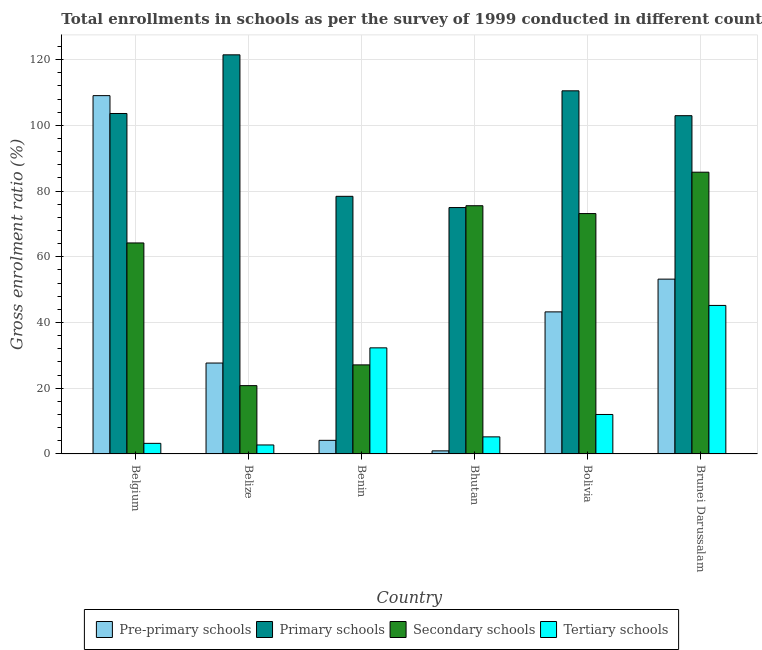Are the number of bars per tick equal to the number of legend labels?
Provide a succinct answer. Yes. Are the number of bars on each tick of the X-axis equal?
Ensure brevity in your answer.  Yes. How many bars are there on the 2nd tick from the right?
Offer a terse response. 4. In how many cases, is the number of bars for a given country not equal to the number of legend labels?
Give a very brief answer. 0. What is the gross enrolment ratio in primary schools in Bolivia?
Your response must be concise. 110.51. Across all countries, what is the maximum gross enrolment ratio in pre-primary schools?
Provide a succinct answer. 109.05. Across all countries, what is the minimum gross enrolment ratio in primary schools?
Offer a terse response. 74.99. In which country was the gross enrolment ratio in pre-primary schools maximum?
Provide a short and direct response. Belgium. In which country was the gross enrolment ratio in pre-primary schools minimum?
Offer a terse response. Bhutan. What is the total gross enrolment ratio in primary schools in the graph?
Make the answer very short. 591.91. What is the difference between the gross enrolment ratio in secondary schools in Belgium and that in Benin?
Make the answer very short. 37.11. What is the difference between the gross enrolment ratio in tertiary schools in Belgium and the gross enrolment ratio in secondary schools in Bhutan?
Offer a terse response. -72.31. What is the average gross enrolment ratio in tertiary schools per country?
Ensure brevity in your answer.  16.78. What is the difference between the gross enrolment ratio in pre-primary schools and gross enrolment ratio in tertiary schools in Belize?
Give a very brief answer. 24.92. In how many countries, is the gross enrolment ratio in primary schools greater than 48 %?
Make the answer very short. 6. What is the ratio of the gross enrolment ratio in primary schools in Bolivia to that in Brunei Darussalam?
Your response must be concise. 1.07. Is the gross enrolment ratio in tertiary schools in Benin less than that in Bolivia?
Your response must be concise. No. What is the difference between the highest and the second highest gross enrolment ratio in secondary schools?
Your answer should be compact. 10.2. What is the difference between the highest and the lowest gross enrolment ratio in pre-primary schools?
Keep it short and to the point. 108.1. What does the 1st bar from the left in Brunei Darussalam represents?
Give a very brief answer. Pre-primary schools. What does the 2nd bar from the right in Bolivia represents?
Your answer should be compact. Secondary schools. Is it the case that in every country, the sum of the gross enrolment ratio in pre-primary schools and gross enrolment ratio in primary schools is greater than the gross enrolment ratio in secondary schools?
Your response must be concise. Yes. How many bars are there?
Keep it short and to the point. 24. What is the difference between two consecutive major ticks on the Y-axis?
Your response must be concise. 20. Are the values on the major ticks of Y-axis written in scientific E-notation?
Offer a very short reply. No. Does the graph contain any zero values?
Keep it short and to the point. No. How are the legend labels stacked?
Make the answer very short. Horizontal. What is the title of the graph?
Offer a very short reply. Total enrollments in schools as per the survey of 1999 conducted in different countries. What is the Gross enrolment ratio (%) in Pre-primary schools in Belgium?
Ensure brevity in your answer.  109.05. What is the Gross enrolment ratio (%) in Primary schools in Belgium?
Offer a very short reply. 103.61. What is the Gross enrolment ratio (%) in Secondary schools in Belgium?
Offer a very short reply. 64.22. What is the Gross enrolment ratio (%) in Tertiary schools in Belgium?
Your response must be concise. 3.23. What is the Gross enrolment ratio (%) in Pre-primary schools in Belize?
Offer a very short reply. 27.67. What is the Gross enrolment ratio (%) of Primary schools in Belize?
Your answer should be compact. 121.46. What is the Gross enrolment ratio (%) of Secondary schools in Belize?
Provide a succinct answer. 20.79. What is the Gross enrolment ratio (%) in Tertiary schools in Belize?
Ensure brevity in your answer.  2.74. What is the Gross enrolment ratio (%) in Pre-primary schools in Benin?
Your answer should be very brief. 4.15. What is the Gross enrolment ratio (%) of Primary schools in Benin?
Give a very brief answer. 78.4. What is the Gross enrolment ratio (%) in Secondary schools in Benin?
Your answer should be compact. 27.11. What is the Gross enrolment ratio (%) of Tertiary schools in Benin?
Ensure brevity in your answer.  32.29. What is the Gross enrolment ratio (%) in Pre-primary schools in Bhutan?
Make the answer very short. 0.94. What is the Gross enrolment ratio (%) in Primary schools in Bhutan?
Keep it short and to the point. 74.99. What is the Gross enrolment ratio (%) of Secondary schools in Bhutan?
Offer a terse response. 75.54. What is the Gross enrolment ratio (%) in Tertiary schools in Bhutan?
Provide a short and direct response. 5.21. What is the Gross enrolment ratio (%) of Pre-primary schools in Bolivia?
Your answer should be compact. 43.24. What is the Gross enrolment ratio (%) in Primary schools in Bolivia?
Provide a succinct answer. 110.51. What is the Gross enrolment ratio (%) of Secondary schools in Bolivia?
Make the answer very short. 73.16. What is the Gross enrolment ratio (%) of Tertiary schools in Bolivia?
Ensure brevity in your answer.  12.02. What is the Gross enrolment ratio (%) in Pre-primary schools in Brunei Darussalam?
Ensure brevity in your answer.  53.2. What is the Gross enrolment ratio (%) in Primary schools in Brunei Darussalam?
Keep it short and to the point. 102.94. What is the Gross enrolment ratio (%) in Secondary schools in Brunei Darussalam?
Give a very brief answer. 85.75. What is the Gross enrolment ratio (%) in Tertiary schools in Brunei Darussalam?
Your answer should be compact. 45.2. Across all countries, what is the maximum Gross enrolment ratio (%) in Pre-primary schools?
Make the answer very short. 109.05. Across all countries, what is the maximum Gross enrolment ratio (%) of Primary schools?
Ensure brevity in your answer.  121.46. Across all countries, what is the maximum Gross enrolment ratio (%) in Secondary schools?
Offer a very short reply. 85.75. Across all countries, what is the maximum Gross enrolment ratio (%) in Tertiary schools?
Offer a terse response. 45.2. Across all countries, what is the minimum Gross enrolment ratio (%) in Pre-primary schools?
Provide a short and direct response. 0.94. Across all countries, what is the minimum Gross enrolment ratio (%) in Primary schools?
Your response must be concise. 74.99. Across all countries, what is the minimum Gross enrolment ratio (%) in Secondary schools?
Ensure brevity in your answer.  20.79. Across all countries, what is the minimum Gross enrolment ratio (%) of Tertiary schools?
Your answer should be compact. 2.74. What is the total Gross enrolment ratio (%) in Pre-primary schools in the graph?
Offer a very short reply. 238.25. What is the total Gross enrolment ratio (%) in Primary schools in the graph?
Provide a succinct answer. 591.91. What is the total Gross enrolment ratio (%) of Secondary schools in the graph?
Provide a succinct answer. 346.56. What is the total Gross enrolment ratio (%) of Tertiary schools in the graph?
Provide a short and direct response. 100.69. What is the difference between the Gross enrolment ratio (%) in Pre-primary schools in Belgium and that in Belize?
Give a very brief answer. 81.38. What is the difference between the Gross enrolment ratio (%) of Primary schools in Belgium and that in Belize?
Offer a very short reply. -17.85. What is the difference between the Gross enrolment ratio (%) in Secondary schools in Belgium and that in Belize?
Make the answer very short. 43.42. What is the difference between the Gross enrolment ratio (%) in Tertiary schools in Belgium and that in Belize?
Your answer should be very brief. 0.49. What is the difference between the Gross enrolment ratio (%) of Pre-primary schools in Belgium and that in Benin?
Offer a very short reply. 104.89. What is the difference between the Gross enrolment ratio (%) of Primary schools in Belgium and that in Benin?
Your answer should be compact. 25.21. What is the difference between the Gross enrolment ratio (%) in Secondary schools in Belgium and that in Benin?
Give a very brief answer. 37.11. What is the difference between the Gross enrolment ratio (%) of Tertiary schools in Belgium and that in Benin?
Offer a very short reply. -29.06. What is the difference between the Gross enrolment ratio (%) of Pre-primary schools in Belgium and that in Bhutan?
Your response must be concise. 108.1. What is the difference between the Gross enrolment ratio (%) in Primary schools in Belgium and that in Bhutan?
Offer a very short reply. 28.62. What is the difference between the Gross enrolment ratio (%) in Secondary schools in Belgium and that in Bhutan?
Your answer should be very brief. -11.33. What is the difference between the Gross enrolment ratio (%) of Tertiary schools in Belgium and that in Bhutan?
Your answer should be compact. -1.98. What is the difference between the Gross enrolment ratio (%) of Pre-primary schools in Belgium and that in Bolivia?
Offer a terse response. 65.81. What is the difference between the Gross enrolment ratio (%) of Primary schools in Belgium and that in Bolivia?
Offer a very short reply. -6.9. What is the difference between the Gross enrolment ratio (%) in Secondary schools in Belgium and that in Bolivia?
Ensure brevity in your answer.  -8.94. What is the difference between the Gross enrolment ratio (%) of Tertiary schools in Belgium and that in Bolivia?
Your answer should be very brief. -8.79. What is the difference between the Gross enrolment ratio (%) in Pre-primary schools in Belgium and that in Brunei Darussalam?
Give a very brief answer. 55.84. What is the difference between the Gross enrolment ratio (%) of Primary schools in Belgium and that in Brunei Darussalam?
Your answer should be very brief. 0.67. What is the difference between the Gross enrolment ratio (%) of Secondary schools in Belgium and that in Brunei Darussalam?
Keep it short and to the point. -21.53. What is the difference between the Gross enrolment ratio (%) of Tertiary schools in Belgium and that in Brunei Darussalam?
Make the answer very short. -41.97. What is the difference between the Gross enrolment ratio (%) in Pre-primary schools in Belize and that in Benin?
Give a very brief answer. 23.52. What is the difference between the Gross enrolment ratio (%) of Primary schools in Belize and that in Benin?
Offer a very short reply. 43.06. What is the difference between the Gross enrolment ratio (%) in Secondary schools in Belize and that in Benin?
Offer a terse response. -6.31. What is the difference between the Gross enrolment ratio (%) of Tertiary schools in Belize and that in Benin?
Ensure brevity in your answer.  -29.55. What is the difference between the Gross enrolment ratio (%) of Pre-primary schools in Belize and that in Bhutan?
Provide a short and direct response. 26.73. What is the difference between the Gross enrolment ratio (%) of Primary schools in Belize and that in Bhutan?
Provide a short and direct response. 46.47. What is the difference between the Gross enrolment ratio (%) in Secondary schools in Belize and that in Bhutan?
Your response must be concise. -54.75. What is the difference between the Gross enrolment ratio (%) in Tertiary schools in Belize and that in Bhutan?
Make the answer very short. -2.46. What is the difference between the Gross enrolment ratio (%) of Pre-primary schools in Belize and that in Bolivia?
Give a very brief answer. -15.57. What is the difference between the Gross enrolment ratio (%) in Primary schools in Belize and that in Bolivia?
Give a very brief answer. 10.95. What is the difference between the Gross enrolment ratio (%) of Secondary schools in Belize and that in Bolivia?
Offer a terse response. -52.36. What is the difference between the Gross enrolment ratio (%) of Tertiary schools in Belize and that in Bolivia?
Your answer should be very brief. -9.28. What is the difference between the Gross enrolment ratio (%) of Pre-primary schools in Belize and that in Brunei Darussalam?
Your answer should be compact. -25.53. What is the difference between the Gross enrolment ratio (%) in Primary schools in Belize and that in Brunei Darussalam?
Make the answer very short. 18.52. What is the difference between the Gross enrolment ratio (%) of Secondary schools in Belize and that in Brunei Darussalam?
Provide a succinct answer. -64.95. What is the difference between the Gross enrolment ratio (%) in Tertiary schools in Belize and that in Brunei Darussalam?
Offer a terse response. -42.46. What is the difference between the Gross enrolment ratio (%) in Pre-primary schools in Benin and that in Bhutan?
Your answer should be very brief. 3.21. What is the difference between the Gross enrolment ratio (%) in Primary schools in Benin and that in Bhutan?
Provide a short and direct response. 3.42. What is the difference between the Gross enrolment ratio (%) of Secondary schools in Benin and that in Bhutan?
Your answer should be very brief. -48.43. What is the difference between the Gross enrolment ratio (%) in Tertiary schools in Benin and that in Bhutan?
Keep it short and to the point. 27.09. What is the difference between the Gross enrolment ratio (%) in Pre-primary schools in Benin and that in Bolivia?
Ensure brevity in your answer.  -39.09. What is the difference between the Gross enrolment ratio (%) in Primary schools in Benin and that in Bolivia?
Your response must be concise. -32.1. What is the difference between the Gross enrolment ratio (%) of Secondary schools in Benin and that in Bolivia?
Ensure brevity in your answer.  -46.05. What is the difference between the Gross enrolment ratio (%) in Tertiary schools in Benin and that in Bolivia?
Keep it short and to the point. 20.27. What is the difference between the Gross enrolment ratio (%) in Pre-primary schools in Benin and that in Brunei Darussalam?
Your answer should be very brief. -49.05. What is the difference between the Gross enrolment ratio (%) of Primary schools in Benin and that in Brunei Darussalam?
Give a very brief answer. -24.54. What is the difference between the Gross enrolment ratio (%) in Secondary schools in Benin and that in Brunei Darussalam?
Offer a very short reply. -58.64. What is the difference between the Gross enrolment ratio (%) in Tertiary schools in Benin and that in Brunei Darussalam?
Offer a very short reply. -12.91. What is the difference between the Gross enrolment ratio (%) in Pre-primary schools in Bhutan and that in Bolivia?
Provide a succinct answer. -42.3. What is the difference between the Gross enrolment ratio (%) in Primary schools in Bhutan and that in Bolivia?
Offer a terse response. -35.52. What is the difference between the Gross enrolment ratio (%) in Secondary schools in Bhutan and that in Bolivia?
Give a very brief answer. 2.39. What is the difference between the Gross enrolment ratio (%) of Tertiary schools in Bhutan and that in Bolivia?
Your response must be concise. -6.81. What is the difference between the Gross enrolment ratio (%) of Pre-primary schools in Bhutan and that in Brunei Darussalam?
Ensure brevity in your answer.  -52.26. What is the difference between the Gross enrolment ratio (%) in Primary schools in Bhutan and that in Brunei Darussalam?
Give a very brief answer. -27.95. What is the difference between the Gross enrolment ratio (%) in Secondary schools in Bhutan and that in Brunei Darussalam?
Provide a short and direct response. -10.2. What is the difference between the Gross enrolment ratio (%) of Tertiary schools in Bhutan and that in Brunei Darussalam?
Your answer should be compact. -40. What is the difference between the Gross enrolment ratio (%) in Pre-primary schools in Bolivia and that in Brunei Darussalam?
Give a very brief answer. -9.96. What is the difference between the Gross enrolment ratio (%) of Primary schools in Bolivia and that in Brunei Darussalam?
Your answer should be compact. 7.57. What is the difference between the Gross enrolment ratio (%) of Secondary schools in Bolivia and that in Brunei Darussalam?
Offer a terse response. -12.59. What is the difference between the Gross enrolment ratio (%) in Tertiary schools in Bolivia and that in Brunei Darussalam?
Ensure brevity in your answer.  -33.18. What is the difference between the Gross enrolment ratio (%) of Pre-primary schools in Belgium and the Gross enrolment ratio (%) of Primary schools in Belize?
Provide a succinct answer. -12.41. What is the difference between the Gross enrolment ratio (%) of Pre-primary schools in Belgium and the Gross enrolment ratio (%) of Secondary schools in Belize?
Your answer should be compact. 88.25. What is the difference between the Gross enrolment ratio (%) of Pre-primary schools in Belgium and the Gross enrolment ratio (%) of Tertiary schools in Belize?
Offer a very short reply. 106.3. What is the difference between the Gross enrolment ratio (%) of Primary schools in Belgium and the Gross enrolment ratio (%) of Secondary schools in Belize?
Offer a terse response. 82.82. What is the difference between the Gross enrolment ratio (%) of Primary schools in Belgium and the Gross enrolment ratio (%) of Tertiary schools in Belize?
Keep it short and to the point. 100.87. What is the difference between the Gross enrolment ratio (%) in Secondary schools in Belgium and the Gross enrolment ratio (%) in Tertiary schools in Belize?
Offer a terse response. 61.47. What is the difference between the Gross enrolment ratio (%) of Pre-primary schools in Belgium and the Gross enrolment ratio (%) of Primary schools in Benin?
Offer a terse response. 30.64. What is the difference between the Gross enrolment ratio (%) in Pre-primary schools in Belgium and the Gross enrolment ratio (%) in Secondary schools in Benin?
Provide a succinct answer. 81.94. What is the difference between the Gross enrolment ratio (%) of Pre-primary schools in Belgium and the Gross enrolment ratio (%) of Tertiary schools in Benin?
Offer a very short reply. 76.75. What is the difference between the Gross enrolment ratio (%) in Primary schools in Belgium and the Gross enrolment ratio (%) in Secondary schools in Benin?
Make the answer very short. 76.5. What is the difference between the Gross enrolment ratio (%) of Primary schools in Belgium and the Gross enrolment ratio (%) of Tertiary schools in Benin?
Your response must be concise. 71.32. What is the difference between the Gross enrolment ratio (%) in Secondary schools in Belgium and the Gross enrolment ratio (%) in Tertiary schools in Benin?
Offer a terse response. 31.92. What is the difference between the Gross enrolment ratio (%) in Pre-primary schools in Belgium and the Gross enrolment ratio (%) in Primary schools in Bhutan?
Make the answer very short. 34.06. What is the difference between the Gross enrolment ratio (%) in Pre-primary schools in Belgium and the Gross enrolment ratio (%) in Secondary schools in Bhutan?
Give a very brief answer. 33.5. What is the difference between the Gross enrolment ratio (%) in Pre-primary schools in Belgium and the Gross enrolment ratio (%) in Tertiary schools in Bhutan?
Keep it short and to the point. 103.84. What is the difference between the Gross enrolment ratio (%) of Primary schools in Belgium and the Gross enrolment ratio (%) of Secondary schools in Bhutan?
Offer a terse response. 28.07. What is the difference between the Gross enrolment ratio (%) in Primary schools in Belgium and the Gross enrolment ratio (%) in Tertiary schools in Bhutan?
Your answer should be very brief. 98.41. What is the difference between the Gross enrolment ratio (%) of Secondary schools in Belgium and the Gross enrolment ratio (%) of Tertiary schools in Bhutan?
Provide a succinct answer. 59.01. What is the difference between the Gross enrolment ratio (%) in Pre-primary schools in Belgium and the Gross enrolment ratio (%) in Primary schools in Bolivia?
Provide a succinct answer. -1.46. What is the difference between the Gross enrolment ratio (%) of Pre-primary schools in Belgium and the Gross enrolment ratio (%) of Secondary schools in Bolivia?
Give a very brief answer. 35.89. What is the difference between the Gross enrolment ratio (%) of Pre-primary schools in Belgium and the Gross enrolment ratio (%) of Tertiary schools in Bolivia?
Ensure brevity in your answer.  97.03. What is the difference between the Gross enrolment ratio (%) in Primary schools in Belgium and the Gross enrolment ratio (%) in Secondary schools in Bolivia?
Make the answer very short. 30.46. What is the difference between the Gross enrolment ratio (%) of Primary schools in Belgium and the Gross enrolment ratio (%) of Tertiary schools in Bolivia?
Keep it short and to the point. 91.59. What is the difference between the Gross enrolment ratio (%) in Secondary schools in Belgium and the Gross enrolment ratio (%) in Tertiary schools in Bolivia?
Ensure brevity in your answer.  52.2. What is the difference between the Gross enrolment ratio (%) in Pre-primary schools in Belgium and the Gross enrolment ratio (%) in Primary schools in Brunei Darussalam?
Your response must be concise. 6.1. What is the difference between the Gross enrolment ratio (%) in Pre-primary schools in Belgium and the Gross enrolment ratio (%) in Secondary schools in Brunei Darussalam?
Make the answer very short. 23.3. What is the difference between the Gross enrolment ratio (%) of Pre-primary schools in Belgium and the Gross enrolment ratio (%) of Tertiary schools in Brunei Darussalam?
Make the answer very short. 63.84. What is the difference between the Gross enrolment ratio (%) of Primary schools in Belgium and the Gross enrolment ratio (%) of Secondary schools in Brunei Darussalam?
Provide a short and direct response. 17.87. What is the difference between the Gross enrolment ratio (%) in Primary schools in Belgium and the Gross enrolment ratio (%) in Tertiary schools in Brunei Darussalam?
Your answer should be very brief. 58.41. What is the difference between the Gross enrolment ratio (%) in Secondary schools in Belgium and the Gross enrolment ratio (%) in Tertiary schools in Brunei Darussalam?
Offer a terse response. 19.01. What is the difference between the Gross enrolment ratio (%) of Pre-primary schools in Belize and the Gross enrolment ratio (%) of Primary schools in Benin?
Keep it short and to the point. -50.73. What is the difference between the Gross enrolment ratio (%) of Pre-primary schools in Belize and the Gross enrolment ratio (%) of Secondary schools in Benin?
Offer a terse response. 0.56. What is the difference between the Gross enrolment ratio (%) of Pre-primary schools in Belize and the Gross enrolment ratio (%) of Tertiary schools in Benin?
Offer a very short reply. -4.62. What is the difference between the Gross enrolment ratio (%) in Primary schools in Belize and the Gross enrolment ratio (%) in Secondary schools in Benin?
Your answer should be very brief. 94.35. What is the difference between the Gross enrolment ratio (%) in Primary schools in Belize and the Gross enrolment ratio (%) in Tertiary schools in Benin?
Provide a short and direct response. 89.17. What is the difference between the Gross enrolment ratio (%) in Secondary schools in Belize and the Gross enrolment ratio (%) in Tertiary schools in Benin?
Make the answer very short. -11.5. What is the difference between the Gross enrolment ratio (%) of Pre-primary schools in Belize and the Gross enrolment ratio (%) of Primary schools in Bhutan?
Your response must be concise. -47.32. What is the difference between the Gross enrolment ratio (%) of Pre-primary schools in Belize and the Gross enrolment ratio (%) of Secondary schools in Bhutan?
Your response must be concise. -47.87. What is the difference between the Gross enrolment ratio (%) in Pre-primary schools in Belize and the Gross enrolment ratio (%) in Tertiary schools in Bhutan?
Keep it short and to the point. 22.46. What is the difference between the Gross enrolment ratio (%) of Primary schools in Belize and the Gross enrolment ratio (%) of Secondary schools in Bhutan?
Your answer should be very brief. 45.92. What is the difference between the Gross enrolment ratio (%) of Primary schools in Belize and the Gross enrolment ratio (%) of Tertiary schools in Bhutan?
Give a very brief answer. 116.26. What is the difference between the Gross enrolment ratio (%) of Secondary schools in Belize and the Gross enrolment ratio (%) of Tertiary schools in Bhutan?
Keep it short and to the point. 15.59. What is the difference between the Gross enrolment ratio (%) in Pre-primary schools in Belize and the Gross enrolment ratio (%) in Primary schools in Bolivia?
Your response must be concise. -82.84. What is the difference between the Gross enrolment ratio (%) of Pre-primary schools in Belize and the Gross enrolment ratio (%) of Secondary schools in Bolivia?
Provide a short and direct response. -45.49. What is the difference between the Gross enrolment ratio (%) of Pre-primary schools in Belize and the Gross enrolment ratio (%) of Tertiary schools in Bolivia?
Your answer should be very brief. 15.65. What is the difference between the Gross enrolment ratio (%) in Primary schools in Belize and the Gross enrolment ratio (%) in Secondary schools in Bolivia?
Your response must be concise. 48.3. What is the difference between the Gross enrolment ratio (%) in Primary schools in Belize and the Gross enrolment ratio (%) in Tertiary schools in Bolivia?
Ensure brevity in your answer.  109.44. What is the difference between the Gross enrolment ratio (%) in Secondary schools in Belize and the Gross enrolment ratio (%) in Tertiary schools in Bolivia?
Offer a very short reply. 8.78. What is the difference between the Gross enrolment ratio (%) in Pre-primary schools in Belize and the Gross enrolment ratio (%) in Primary schools in Brunei Darussalam?
Provide a succinct answer. -75.27. What is the difference between the Gross enrolment ratio (%) of Pre-primary schools in Belize and the Gross enrolment ratio (%) of Secondary schools in Brunei Darussalam?
Keep it short and to the point. -58.08. What is the difference between the Gross enrolment ratio (%) in Pre-primary schools in Belize and the Gross enrolment ratio (%) in Tertiary schools in Brunei Darussalam?
Provide a short and direct response. -17.53. What is the difference between the Gross enrolment ratio (%) of Primary schools in Belize and the Gross enrolment ratio (%) of Secondary schools in Brunei Darussalam?
Your answer should be very brief. 35.71. What is the difference between the Gross enrolment ratio (%) of Primary schools in Belize and the Gross enrolment ratio (%) of Tertiary schools in Brunei Darussalam?
Your response must be concise. 76.26. What is the difference between the Gross enrolment ratio (%) of Secondary schools in Belize and the Gross enrolment ratio (%) of Tertiary schools in Brunei Darussalam?
Your answer should be compact. -24.41. What is the difference between the Gross enrolment ratio (%) of Pre-primary schools in Benin and the Gross enrolment ratio (%) of Primary schools in Bhutan?
Provide a succinct answer. -70.84. What is the difference between the Gross enrolment ratio (%) of Pre-primary schools in Benin and the Gross enrolment ratio (%) of Secondary schools in Bhutan?
Offer a terse response. -71.39. What is the difference between the Gross enrolment ratio (%) in Pre-primary schools in Benin and the Gross enrolment ratio (%) in Tertiary schools in Bhutan?
Provide a succinct answer. -1.05. What is the difference between the Gross enrolment ratio (%) in Primary schools in Benin and the Gross enrolment ratio (%) in Secondary schools in Bhutan?
Offer a terse response. 2.86. What is the difference between the Gross enrolment ratio (%) in Primary schools in Benin and the Gross enrolment ratio (%) in Tertiary schools in Bhutan?
Your answer should be very brief. 73.2. What is the difference between the Gross enrolment ratio (%) in Secondary schools in Benin and the Gross enrolment ratio (%) in Tertiary schools in Bhutan?
Ensure brevity in your answer.  21.9. What is the difference between the Gross enrolment ratio (%) of Pre-primary schools in Benin and the Gross enrolment ratio (%) of Primary schools in Bolivia?
Make the answer very short. -106.36. What is the difference between the Gross enrolment ratio (%) of Pre-primary schools in Benin and the Gross enrolment ratio (%) of Secondary schools in Bolivia?
Make the answer very short. -69.01. What is the difference between the Gross enrolment ratio (%) of Pre-primary schools in Benin and the Gross enrolment ratio (%) of Tertiary schools in Bolivia?
Keep it short and to the point. -7.87. What is the difference between the Gross enrolment ratio (%) of Primary schools in Benin and the Gross enrolment ratio (%) of Secondary schools in Bolivia?
Your answer should be very brief. 5.25. What is the difference between the Gross enrolment ratio (%) in Primary schools in Benin and the Gross enrolment ratio (%) in Tertiary schools in Bolivia?
Provide a short and direct response. 66.38. What is the difference between the Gross enrolment ratio (%) of Secondary schools in Benin and the Gross enrolment ratio (%) of Tertiary schools in Bolivia?
Your answer should be compact. 15.09. What is the difference between the Gross enrolment ratio (%) of Pre-primary schools in Benin and the Gross enrolment ratio (%) of Primary schools in Brunei Darussalam?
Provide a short and direct response. -98.79. What is the difference between the Gross enrolment ratio (%) of Pre-primary schools in Benin and the Gross enrolment ratio (%) of Secondary schools in Brunei Darussalam?
Offer a terse response. -81.6. What is the difference between the Gross enrolment ratio (%) of Pre-primary schools in Benin and the Gross enrolment ratio (%) of Tertiary schools in Brunei Darussalam?
Your response must be concise. -41.05. What is the difference between the Gross enrolment ratio (%) of Primary schools in Benin and the Gross enrolment ratio (%) of Secondary schools in Brunei Darussalam?
Offer a very short reply. -7.34. What is the difference between the Gross enrolment ratio (%) of Primary schools in Benin and the Gross enrolment ratio (%) of Tertiary schools in Brunei Darussalam?
Make the answer very short. 33.2. What is the difference between the Gross enrolment ratio (%) of Secondary schools in Benin and the Gross enrolment ratio (%) of Tertiary schools in Brunei Darussalam?
Provide a succinct answer. -18.09. What is the difference between the Gross enrolment ratio (%) of Pre-primary schools in Bhutan and the Gross enrolment ratio (%) of Primary schools in Bolivia?
Make the answer very short. -109.56. What is the difference between the Gross enrolment ratio (%) in Pre-primary schools in Bhutan and the Gross enrolment ratio (%) in Secondary schools in Bolivia?
Ensure brevity in your answer.  -72.21. What is the difference between the Gross enrolment ratio (%) of Pre-primary schools in Bhutan and the Gross enrolment ratio (%) of Tertiary schools in Bolivia?
Keep it short and to the point. -11.08. What is the difference between the Gross enrolment ratio (%) in Primary schools in Bhutan and the Gross enrolment ratio (%) in Secondary schools in Bolivia?
Ensure brevity in your answer.  1.83. What is the difference between the Gross enrolment ratio (%) of Primary schools in Bhutan and the Gross enrolment ratio (%) of Tertiary schools in Bolivia?
Your answer should be compact. 62.97. What is the difference between the Gross enrolment ratio (%) of Secondary schools in Bhutan and the Gross enrolment ratio (%) of Tertiary schools in Bolivia?
Ensure brevity in your answer.  63.52. What is the difference between the Gross enrolment ratio (%) in Pre-primary schools in Bhutan and the Gross enrolment ratio (%) in Primary schools in Brunei Darussalam?
Your response must be concise. -102. What is the difference between the Gross enrolment ratio (%) in Pre-primary schools in Bhutan and the Gross enrolment ratio (%) in Secondary schools in Brunei Darussalam?
Provide a succinct answer. -84.8. What is the difference between the Gross enrolment ratio (%) in Pre-primary schools in Bhutan and the Gross enrolment ratio (%) in Tertiary schools in Brunei Darussalam?
Offer a very short reply. -44.26. What is the difference between the Gross enrolment ratio (%) of Primary schools in Bhutan and the Gross enrolment ratio (%) of Secondary schools in Brunei Darussalam?
Ensure brevity in your answer.  -10.76. What is the difference between the Gross enrolment ratio (%) in Primary schools in Bhutan and the Gross enrolment ratio (%) in Tertiary schools in Brunei Darussalam?
Your response must be concise. 29.79. What is the difference between the Gross enrolment ratio (%) in Secondary schools in Bhutan and the Gross enrolment ratio (%) in Tertiary schools in Brunei Darussalam?
Your answer should be compact. 30.34. What is the difference between the Gross enrolment ratio (%) of Pre-primary schools in Bolivia and the Gross enrolment ratio (%) of Primary schools in Brunei Darussalam?
Your answer should be very brief. -59.7. What is the difference between the Gross enrolment ratio (%) of Pre-primary schools in Bolivia and the Gross enrolment ratio (%) of Secondary schools in Brunei Darussalam?
Your answer should be compact. -42.51. What is the difference between the Gross enrolment ratio (%) of Pre-primary schools in Bolivia and the Gross enrolment ratio (%) of Tertiary schools in Brunei Darussalam?
Ensure brevity in your answer.  -1.96. What is the difference between the Gross enrolment ratio (%) of Primary schools in Bolivia and the Gross enrolment ratio (%) of Secondary schools in Brunei Darussalam?
Keep it short and to the point. 24.76. What is the difference between the Gross enrolment ratio (%) in Primary schools in Bolivia and the Gross enrolment ratio (%) in Tertiary schools in Brunei Darussalam?
Provide a succinct answer. 65.31. What is the difference between the Gross enrolment ratio (%) of Secondary schools in Bolivia and the Gross enrolment ratio (%) of Tertiary schools in Brunei Darussalam?
Provide a succinct answer. 27.95. What is the average Gross enrolment ratio (%) of Pre-primary schools per country?
Offer a very short reply. 39.71. What is the average Gross enrolment ratio (%) in Primary schools per country?
Offer a terse response. 98.65. What is the average Gross enrolment ratio (%) in Secondary schools per country?
Offer a very short reply. 57.76. What is the average Gross enrolment ratio (%) in Tertiary schools per country?
Give a very brief answer. 16.78. What is the difference between the Gross enrolment ratio (%) in Pre-primary schools and Gross enrolment ratio (%) in Primary schools in Belgium?
Keep it short and to the point. 5.43. What is the difference between the Gross enrolment ratio (%) of Pre-primary schools and Gross enrolment ratio (%) of Secondary schools in Belgium?
Your answer should be very brief. 44.83. What is the difference between the Gross enrolment ratio (%) of Pre-primary schools and Gross enrolment ratio (%) of Tertiary schools in Belgium?
Your answer should be very brief. 105.82. What is the difference between the Gross enrolment ratio (%) of Primary schools and Gross enrolment ratio (%) of Secondary schools in Belgium?
Offer a terse response. 39.4. What is the difference between the Gross enrolment ratio (%) of Primary schools and Gross enrolment ratio (%) of Tertiary schools in Belgium?
Give a very brief answer. 100.38. What is the difference between the Gross enrolment ratio (%) in Secondary schools and Gross enrolment ratio (%) in Tertiary schools in Belgium?
Your answer should be compact. 60.99. What is the difference between the Gross enrolment ratio (%) of Pre-primary schools and Gross enrolment ratio (%) of Primary schools in Belize?
Offer a terse response. -93.79. What is the difference between the Gross enrolment ratio (%) of Pre-primary schools and Gross enrolment ratio (%) of Secondary schools in Belize?
Your response must be concise. 6.87. What is the difference between the Gross enrolment ratio (%) in Pre-primary schools and Gross enrolment ratio (%) in Tertiary schools in Belize?
Your answer should be very brief. 24.93. What is the difference between the Gross enrolment ratio (%) of Primary schools and Gross enrolment ratio (%) of Secondary schools in Belize?
Keep it short and to the point. 100.67. What is the difference between the Gross enrolment ratio (%) in Primary schools and Gross enrolment ratio (%) in Tertiary schools in Belize?
Make the answer very short. 118.72. What is the difference between the Gross enrolment ratio (%) of Secondary schools and Gross enrolment ratio (%) of Tertiary schools in Belize?
Your response must be concise. 18.05. What is the difference between the Gross enrolment ratio (%) in Pre-primary schools and Gross enrolment ratio (%) in Primary schools in Benin?
Ensure brevity in your answer.  -74.25. What is the difference between the Gross enrolment ratio (%) of Pre-primary schools and Gross enrolment ratio (%) of Secondary schools in Benin?
Offer a very short reply. -22.96. What is the difference between the Gross enrolment ratio (%) of Pre-primary schools and Gross enrolment ratio (%) of Tertiary schools in Benin?
Your answer should be compact. -28.14. What is the difference between the Gross enrolment ratio (%) of Primary schools and Gross enrolment ratio (%) of Secondary schools in Benin?
Provide a short and direct response. 51.3. What is the difference between the Gross enrolment ratio (%) in Primary schools and Gross enrolment ratio (%) in Tertiary schools in Benin?
Your answer should be compact. 46.11. What is the difference between the Gross enrolment ratio (%) of Secondary schools and Gross enrolment ratio (%) of Tertiary schools in Benin?
Provide a succinct answer. -5.19. What is the difference between the Gross enrolment ratio (%) in Pre-primary schools and Gross enrolment ratio (%) in Primary schools in Bhutan?
Your answer should be very brief. -74.04. What is the difference between the Gross enrolment ratio (%) of Pre-primary schools and Gross enrolment ratio (%) of Secondary schools in Bhutan?
Provide a succinct answer. -74.6. What is the difference between the Gross enrolment ratio (%) of Pre-primary schools and Gross enrolment ratio (%) of Tertiary schools in Bhutan?
Give a very brief answer. -4.26. What is the difference between the Gross enrolment ratio (%) of Primary schools and Gross enrolment ratio (%) of Secondary schools in Bhutan?
Give a very brief answer. -0.55. What is the difference between the Gross enrolment ratio (%) in Primary schools and Gross enrolment ratio (%) in Tertiary schools in Bhutan?
Your answer should be compact. 69.78. What is the difference between the Gross enrolment ratio (%) in Secondary schools and Gross enrolment ratio (%) in Tertiary schools in Bhutan?
Make the answer very short. 70.34. What is the difference between the Gross enrolment ratio (%) of Pre-primary schools and Gross enrolment ratio (%) of Primary schools in Bolivia?
Keep it short and to the point. -67.27. What is the difference between the Gross enrolment ratio (%) in Pre-primary schools and Gross enrolment ratio (%) in Secondary schools in Bolivia?
Offer a terse response. -29.92. What is the difference between the Gross enrolment ratio (%) of Pre-primary schools and Gross enrolment ratio (%) of Tertiary schools in Bolivia?
Your answer should be very brief. 31.22. What is the difference between the Gross enrolment ratio (%) in Primary schools and Gross enrolment ratio (%) in Secondary schools in Bolivia?
Provide a succinct answer. 37.35. What is the difference between the Gross enrolment ratio (%) of Primary schools and Gross enrolment ratio (%) of Tertiary schools in Bolivia?
Provide a short and direct response. 98.49. What is the difference between the Gross enrolment ratio (%) in Secondary schools and Gross enrolment ratio (%) in Tertiary schools in Bolivia?
Provide a succinct answer. 61.14. What is the difference between the Gross enrolment ratio (%) of Pre-primary schools and Gross enrolment ratio (%) of Primary schools in Brunei Darussalam?
Keep it short and to the point. -49.74. What is the difference between the Gross enrolment ratio (%) of Pre-primary schools and Gross enrolment ratio (%) of Secondary schools in Brunei Darussalam?
Give a very brief answer. -32.54. What is the difference between the Gross enrolment ratio (%) in Pre-primary schools and Gross enrolment ratio (%) in Tertiary schools in Brunei Darussalam?
Provide a short and direct response. 8. What is the difference between the Gross enrolment ratio (%) in Primary schools and Gross enrolment ratio (%) in Secondary schools in Brunei Darussalam?
Provide a short and direct response. 17.2. What is the difference between the Gross enrolment ratio (%) of Primary schools and Gross enrolment ratio (%) of Tertiary schools in Brunei Darussalam?
Offer a very short reply. 57.74. What is the difference between the Gross enrolment ratio (%) of Secondary schools and Gross enrolment ratio (%) of Tertiary schools in Brunei Darussalam?
Provide a short and direct response. 40.54. What is the ratio of the Gross enrolment ratio (%) in Pre-primary schools in Belgium to that in Belize?
Provide a succinct answer. 3.94. What is the ratio of the Gross enrolment ratio (%) of Primary schools in Belgium to that in Belize?
Offer a terse response. 0.85. What is the ratio of the Gross enrolment ratio (%) of Secondary schools in Belgium to that in Belize?
Offer a very short reply. 3.09. What is the ratio of the Gross enrolment ratio (%) of Tertiary schools in Belgium to that in Belize?
Provide a succinct answer. 1.18. What is the ratio of the Gross enrolment ratio (%) of Pre-primary schools in Belgium to that in Benin?
Make the answer very short. 26.27. What is the ratio of the Gross enrolment ratio (%) in Primary schools in Belgium to that in Benin?
Offer a terse response. 1.32. What is the ratio of the Gross enrolment ratio (%) in Secondary schools in Belgium to that in Benin?
Give a very brief answer. 2.37. What is the ratio of the Gross enrolment ratio (%) of Tertiary schools in Belgium to that in Benin?
Offer a very short reply. 0.1. What is the ratio of the Gross enrolment ratio (%) in Pre-primary schools in Belgium to that in Bhutan?
Provide a short and direct response. 115.6. What is the ratio of the Gross enrolment ratio (%) in Primary schools in Belgium to that in Bhutan?
Keep it short and to the point. 1.38. What is the ratio of the Gross enrolment ratio (%) in Secondary schools in Belgium to that in Bhutan?
Provide a succinct answer. 0.85. What is the ratio of the Gross enrolment ratio (%) of Tertiary schools in Belgium to that in Bhutan?
Ensure brevity in your answer.  0.62. What is the ratio of the Gross enrolment ratio (%) of Pre-primary schools in Belgium to that in Bolivia?
Your response must be concise. 2.52. What is the ratio of the Gross enrolment ratio (%) of Primary schools in Belgium to that in Bolivia?
Offer a terse response. 0.94. What is the ratio of the Gross enrolment ratio (%) of Secondary schools in Belgium to that in Bolivia?
Make the answer very short. 0.88. What is the ratio of the Gross enrolment ratio (%) in Tertiary schools in Belgium to that in Bolivia?
Ensure brevity in your answer.  0.27. What is the ratio of the Gross enrolment ratio (%) of Pre-primary schools in Belgium to that in Brunei Darussalam?
Offer a terse response. 2.05. What is the ratio of the Gross enrolment ratio (%) in Secondary schools in Belgium to that in Brunei Darussalam?
Your answer should be very brief. 0.75. What is the ratio of the Gross enrolment ratio (%) in Tertiary schools in Belgium to that in Brunei Darussalam?
Ensure brevity in your answer.  0.07. What is the ratio of the Gross enrolment ratio (%) of Pre-primary schools in Belize to that in Benin?
Your answer should be very brief. 6.67. What is the ratio of the Gross enrolment ratio (%) in Primary schools in Belize to that in Benin?
Give a very brief answer. 1.55. What is the ratio of the Gross enrolment ratio (%) of Secondary schools in Belize to that in Benin?
Offer a very short reply. 0.77. What is the ratio of the Gross enrolment ratio (%) of Tertiary schools in Belize to that in Benin?
Offer a very short reply. 0.09. What is the ratio of the Gross enrolment ratio (%) of Pre-primary schools in Belize to that in Bhutan?
Your answer should be very brief. 29.33. What is the ratio of the Gross enrolment ratio (%) in Primary schools in Belize to that in Bhutan?
Offer a terse response. 1.62. What is the ratio of the Gross enrolment ratio (%) in Secondary schools in Belize to that in Bhutan?
Your answer should be very brief. 0.28. What is the ratio of the Gross enrolment ratio (%) of Tertiary schools in Belize to that in Bhutan?
Ensure brevity in your answer.  0.53. What is the ratio of the Gross enrolment ratio (%) of Pre-primary schools in Belize to that in Bolivia?
Your answer should be compact. 0.64. What is the ratio of the Gross enrolment ratio (%) in Primary schools in Belize to that in Bolivia?
Offer a terse response. 1.1. What is the ratio of the Gross enrolment ratio (%) in Secondary schools in Belize to that in Bolivia?
Offer a very short reply. 0.28. What is the ratio of the Gross enrolment ratio (%) in Tertiary schools in Belize to that in Bolivia?
Provide a short and direct response. 0.23. What is the ratio of the Gross enrolment ratio (%) in Pre-primary schools in Belize to that in Brunei Darussalam?
Your response must be concise. 0.52. What is the ratio of the Gross enrolment ratio (%) in Primary schools in Belize to that in Brunei Darussalam?
Offer a terse response. 1.18. What is the ratio of the Gross enrolment ratio (%) of Secondary schools in Belize to that in Brunei Darussalam?
Make the answer very short. 0.24. What is the ratio of the Gross enrolment ratio (%) in Tertiary schools in Belize to that in Brunei Darussalam?
Provide a short and direct response. 0.06. What is the ratio of the Gross enrolment ratio (%) of Pre-primary schools in Benin to that in Bhutan?
Keep it short and to the point. 4.4. What is the ratio of the Gross enrolment ratio (%) in Primary schools in Benin to that in Bhutan?
Provide a short and direct response. 1.05. What is the ratio of the Gross enrolment ratio (%) in Secondary schools in Benin to that in Bhutan?
Ensure brevity in your answer.  0.36. What is the ratio of the Gross enrolment ratio (%) of Tertiary schools in Benin to that in Bhutan?
Offer a terse response. 6.2. What is the ratio of the Gross enrolment ratio (%) of Pre-primary schools in Benin to that in Bolivia?
Provide a short and direct response. 0.1. What is the ratio of the Gross enrolment ratio (%) in Primary schools in Benin to that in Bolivia?
Offer a very short reply. 0.71. What is the ratio of the Gross enrolment ratio (%) of Secondary schools in Benin to that in Bolivia?
Make the answer very short. 0.37. What is the ratio of the Gross enrolment ratio (%) in Tertiary schools in Benin to that in Bolivia?
Make the answer very short. 2.69. What is the ratio of the Gross enrolment ratio (%) in Pre-primary schools in Benin to that in Brunei Darussalam?
Offer a very short reply. 0.08. What is the ratio of the Gross enrolment ratio (%) in Primary schools in Benin to that in Brunei Darussalam?
Make the answer very short. 0.76. What is the ratio of the Gross enrolment ratio (%) of Secondary schools in Benin to that in Brunei Darussalam?
Your response must be concise. 0.32. What is the ratio of the Gross enrolment ratio (%) of Tertiary schools in Benin to that in Brunei Darussalam?
Keep it short and to the point. 0.71. What is the ratio of the Gross enrolment ratio (%) of Pre-primary schools in Bhutan to that in Bolivia?
Make the answer very short. 0.02. What is the ratio of the Gross enrolment ratio (%) in Primary schools in Bhutan to that in Bolivia?
Provide a short and direct response. 0.68. What is the ratio of the Gross enrolment ratio (%) of Secondary schools in Bhutan to that in Bolivia?
Ensure brevity in your answer.  1.03. What is the ratio of the Gross enrolment ratio (%) in Tertiary schools in Bhutan to that in Bolivia?
Give a very brief answer. 0.43. What is the ratio of the Gross enrolment ratio (%) of Pre-primary schools in Bhutan to that in Brunei Darussalam?
Offer a very short reply. 0.02. What is the ratio of the Gross enrolment ratio (%) of Primary schools in Bhutan to that in Brunei Darussalam?
Ensure brevity in your answer.  0.73. What is the ratio of the Gross enrolment ratio (%) in Secondary schools in Bhutan to that in Brunei Darussalam?
Your answer should be compact. 0.88. What is the ratio of the Gross enrolment ratio (%) in Tertiary schools in Bhutan to that in Brunei Darussalam?
Your answer should be very brief. 0.12. What is the ratio of the Gross enrolment ratio (%) in Pre-primary schools in Bolivia to that in Brunei Darussalam?
Your answer should be very brief. 0.81. What is the ratio of the Gross enrolment ratio (%) of Primary schools in Bolivia to that in Brunei Darussalam?
Ensure brevity in your answer.  1.07. What is the ratio of the Gross enrolment ratio (%) of Secondary schools in Bolivia to that in Brunei Darussalam?
Make the answer very short. 0.85. What is the ratio of the Gross enrolment ratio (%) in Tertiary schools in Bolivia to that in Brunei Darussalam?
Make the answer very short. 0.27. What is the difference between the highest and the second highest Gross enrolment ratio (%) in Pre-primary schools?
Your answer should be very brief. 55.84. What is the difference between the highest and the second highest Gross enrolment ratio (%) in Primary schools?
Offer a very short reply. 10.95. What is the difference between the highest and the second highest Gross enrolment ratio (%) in Secondary schools?
Your answer should be very brief. 10.2. What is the difference between the highest and the second highest Gross enrolment ratio (%) in Tertiary schools?
Ensure brevity in your answer.  12.91. What is the difference between the highest and the lowest Gross enrolment ratio (%) of Pre-primary schools?
Your answer should be compact. 108.1. What is the difference between the highest and the lowest Gross enrolment ratio (%) of Primary schools?
Keep it short and to the point. 46.47. What is the difference between the highest and the lowest Gross enrolment ratio (%) of Secondary schools?
Offer a terse response. 64.95. What is the difference between the highest and the lowest Gross enrolment ratio (%) of Tertiary schools?
Make the answer very short. 42.46. 